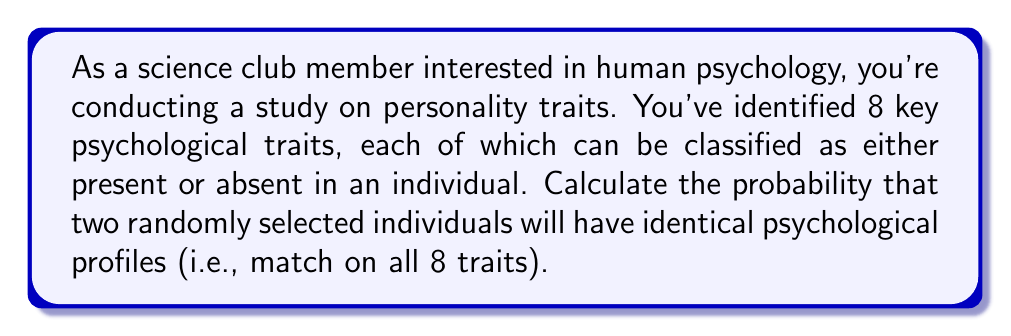Can you answer this question? To solve this problem, let's break it down into steps:

1) First, we need to understand what the question is asking. We're looking for the probability that two people will have exactly the same combination of traits out of 8 possible traits.

2) Each trait can be either present or absent, which means for each trait, there are 2 possibilities.

3) With 8 traits, each person's psychological profile can be represented as a sequence of 8 binary choices. The total number of possible profiles is therefore:

   $$ 2^8 = 256 $$

4) For two people to have identical profiles, they must match on all 8 traits. The probability of this happening can be calculated as follows:

   - For the first person, any profile is acceptable (probability 1)
   - For the second person, they must match the first person exactly

5) The probability of matching on a single trait is 1/2 (either present or absent).

6) For all 8 traits to match, we multiply these probabilities:

   $$ P(\text{all traits match}) = (\frac{1}{2})^8 = \frac{1}{256} $$

This is equivalent to 1 divided by the total number of possible profiles we calculated earlier.
Answer: The probability that two randomly selected individuals will have identical psychological profiles across all 8 traits is $\frac{1}{256}$ or approximately 0.00390625. 